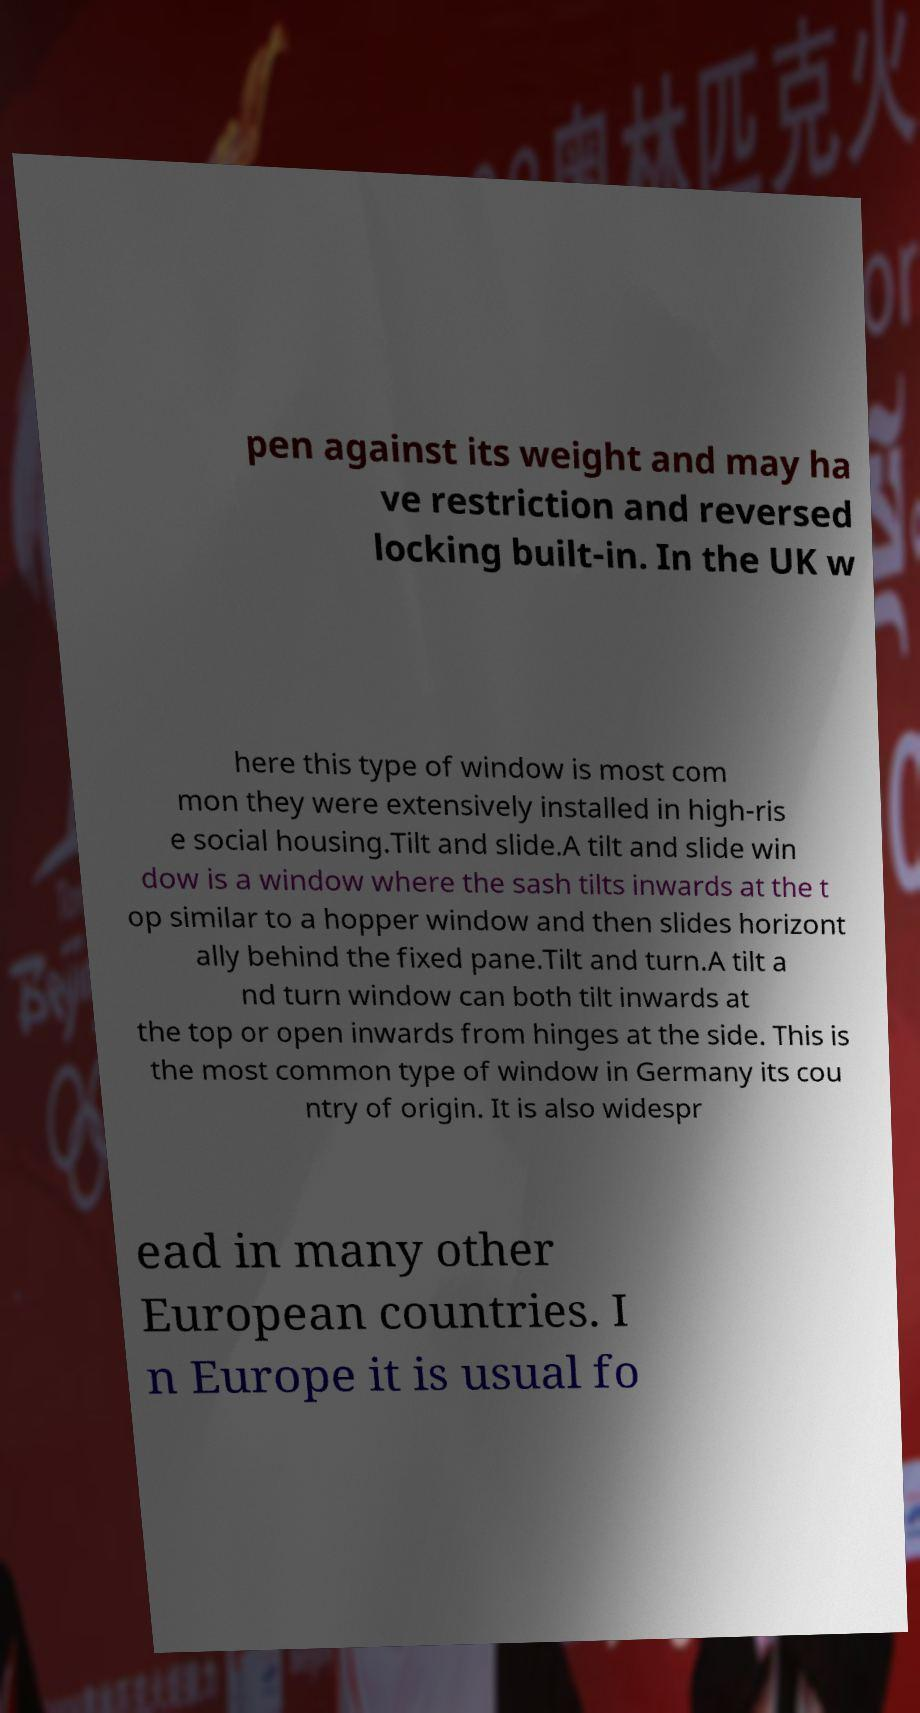What messages or text are displayed in this image? I need them in a readable, typed format. pen against its weight and may ha ve restriction and reversed locking built-in. In the UK w here this type of window is most com mon they were extensively installed in high-ris e social housing.Tilt and slide.A tilt and slide win dow is a window where the sash tilts inwards at the t op similar to a hopper window and then slides horizont ally behind the fixed pane.Tilt and turn.A tilt a nd turn window can both tilt inwards at the top or open inwards from hinges at the side. This is the most common type of window in Germany its cou ntry of origin. It is also widespr ead in many other European countries. I n Europe it is usual fo 